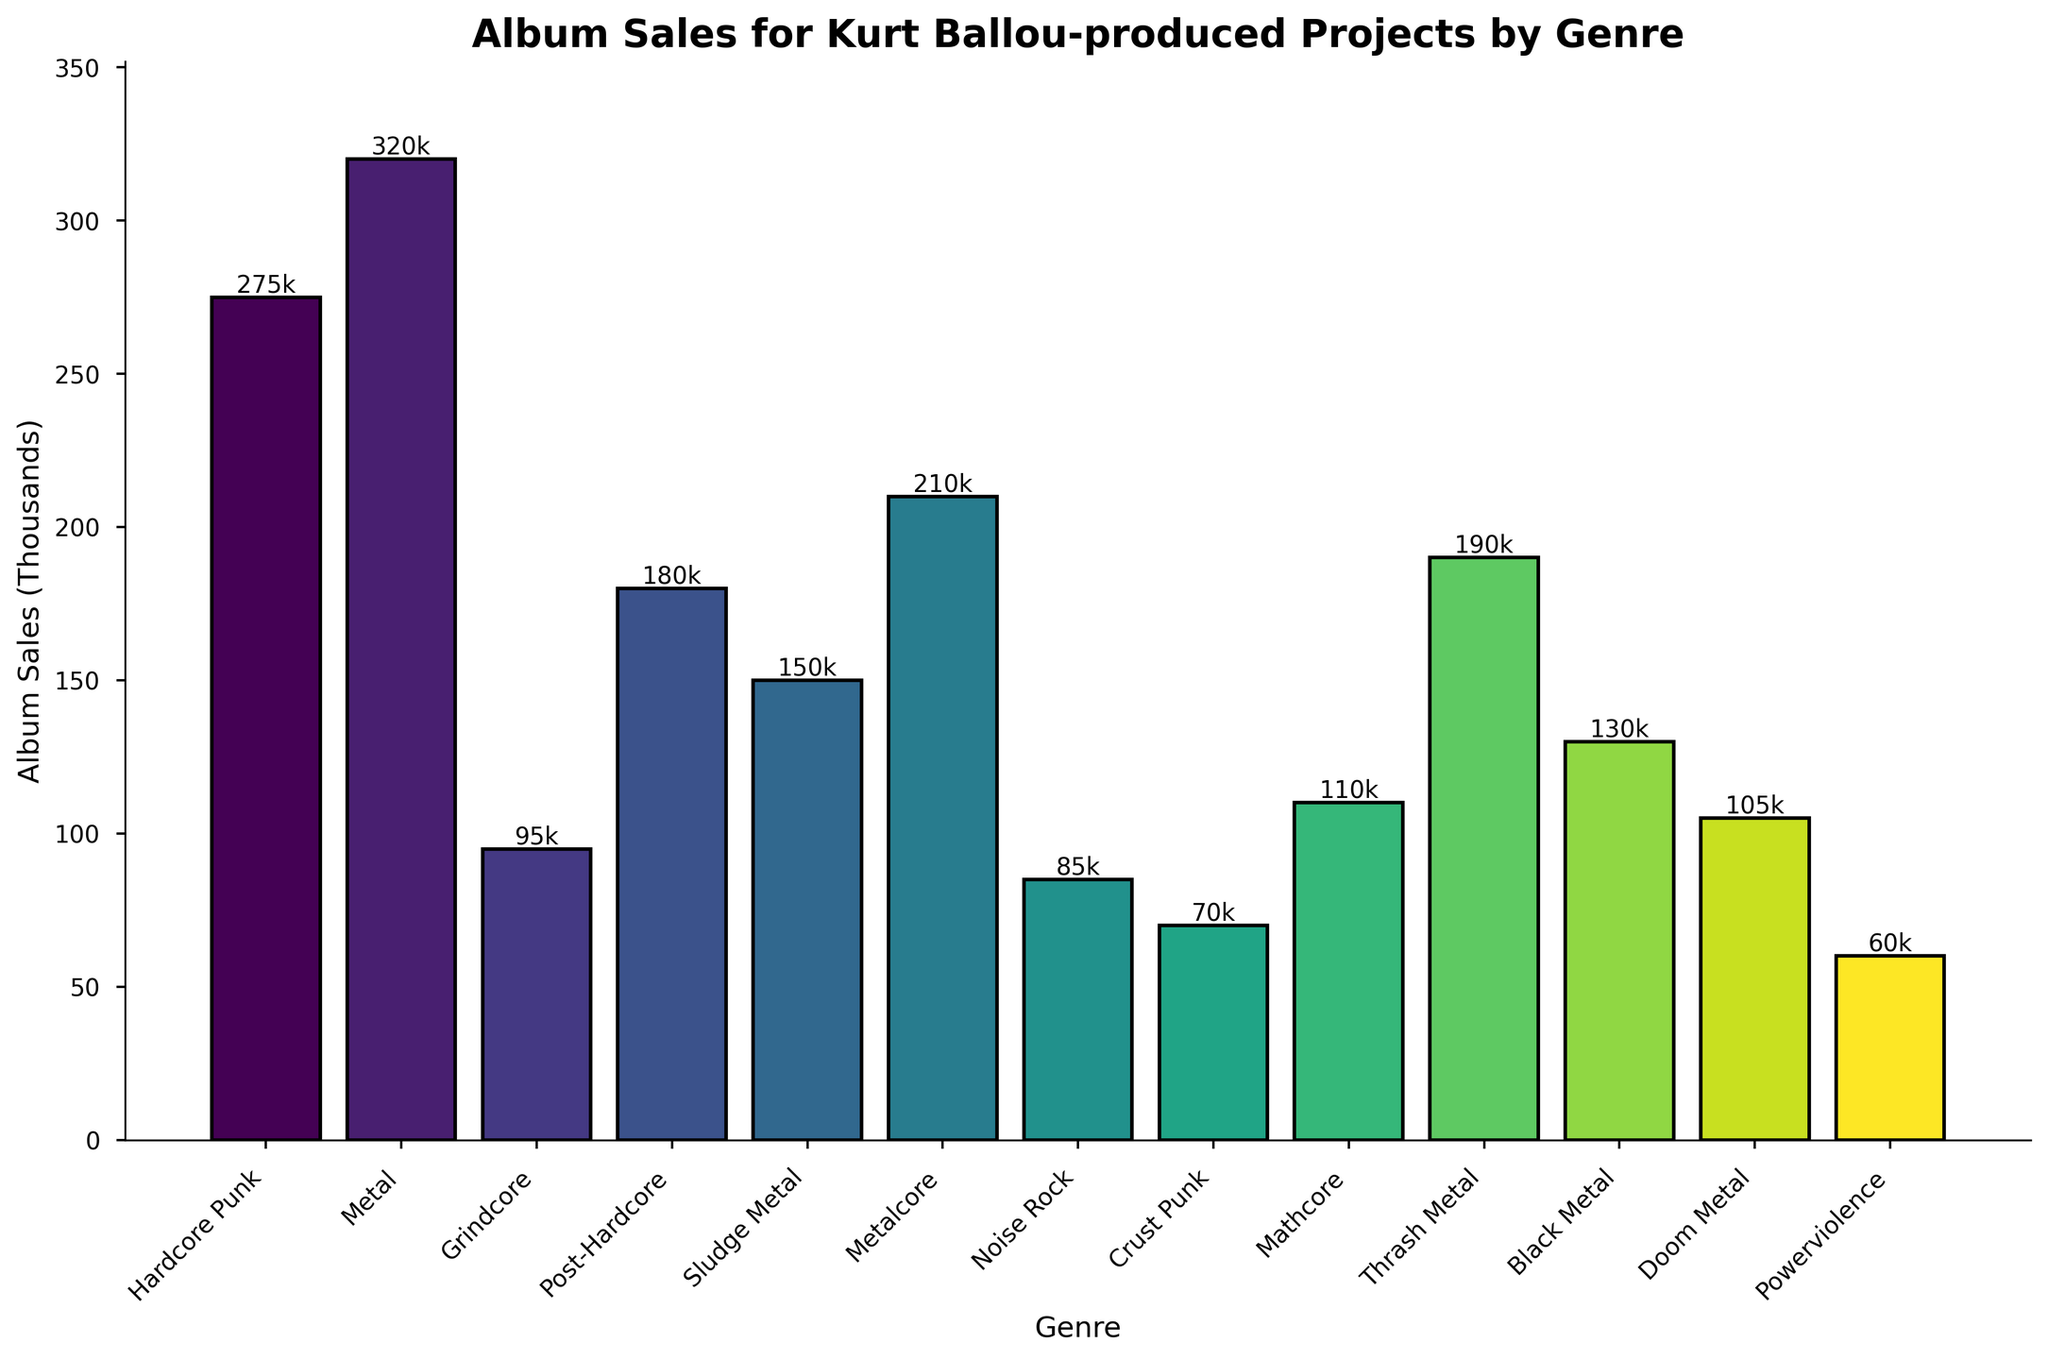Which genre has the highest album sales? By looking at the height of each bar in the bar chart, we can determine which bar is the tallest. The 'Metal' genre bar is the tallest, indicating it has the highest album sales.
Answer: Metal What is the combined album sales for Post-Hardcore and Metalcore genres? Identify the heights (values) of the bars corresponding to Post-Hardcore (180,000) and Metalcore (210,000). Sum these values to get the combined sales: 180,000 + 210,000 = 390,000.
Answer: 390,000 How do the album sales of Hardcore Punk compare to Grindcore? Look at the heights of the bars corresponding to Hardcore Punk (275,000) and Grindcore (95,000) and compare them. The Hardcore Punk bar is significantly taller.
Answer: Hardcore Punk is higher Which genre has slightly higher album sales, Mathcore or Doom Metal? Compare the heights of the bars for Mathcore (110,000) and Doom Metal (105,000). Mathcore has a marginally taller bar.
Answer: Mathcore What's the difference in album sales between Thrash Metal and Black Metal? Determine the heights of the bars for Thrash Metal (190,000) and Black Metal (130,000) and subtract the latter from the former: 190,000 - 130,000 = 60,000.
Answer: 60,000 What is the median album sales value across all genres? List the album sales in ascending order: 60,000, 70,000, 85,000, 95,000, 105,000, 110,000, 130,000, 150,000, 180,000, 190,000, 210,000, 275,000, 320,000. The middle value (7th value) in this ordered list is the median: 130,000.
Answer: 130,000 What's the total album sales for all genres combined? Sum the values of all album sales: 275,000 + 320,000 + 95,000 + 180,000 + 150,000 + 210,000 + 85,000 + 70,000 + 110,000 + 190,000 + 130,000 + 105,000 + 60,000 = 1,980,000.
Answer: 1,980,000 Are the album sales of Powerviolence higher or lower than Noise Rock? Compare the heights of the bars for Powerviolence (60,000) and Noise Rock (85,000). Powerviolence's bar is shorter, indicating lower sales.
Answer: Lower What percentage of total sales does the Metal genre represent? Calculate the total album sales (1,980,000) and then find the share of the Metal genre (320,000): (320,000 / 1,980,000) * 100 = 16.16%.
Answer: 16.16% Which three genres have the lowest album sales? Identify the three shortest bars in the chart corresponding to Powerviolence (60,000), Crust Punk (70,000), and Noise Rock (85,000).
Answer: Powerviolence, Crust Punk, Noise Rock 